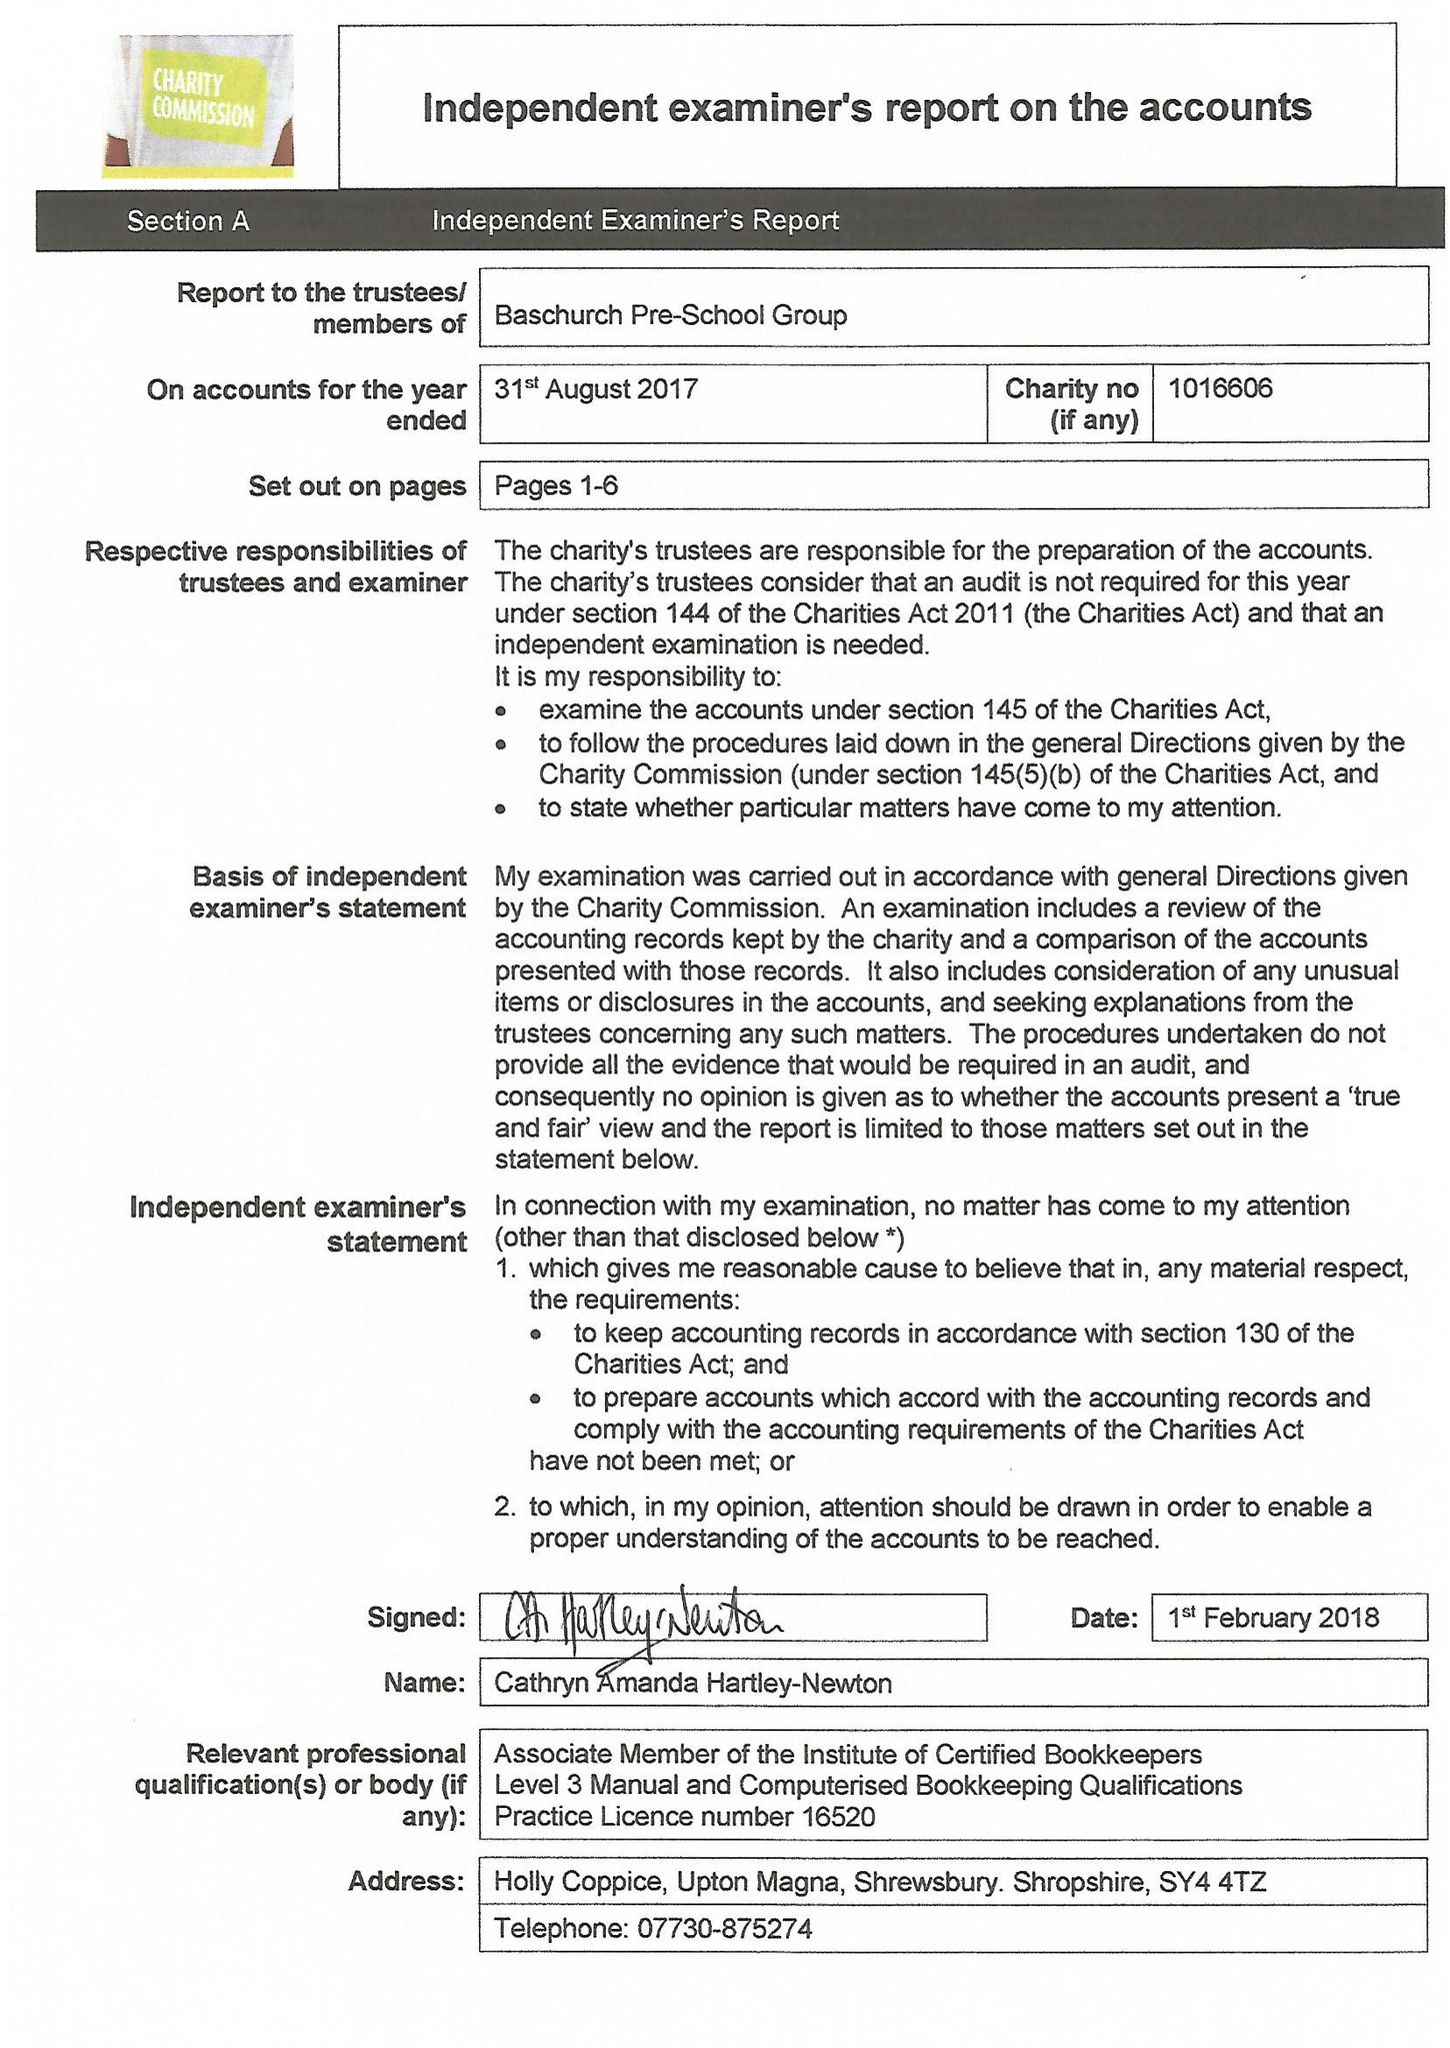What is the value for the spending_annually_in_british_pounds?
Answer the question using a single word or phrase. 104410.00 